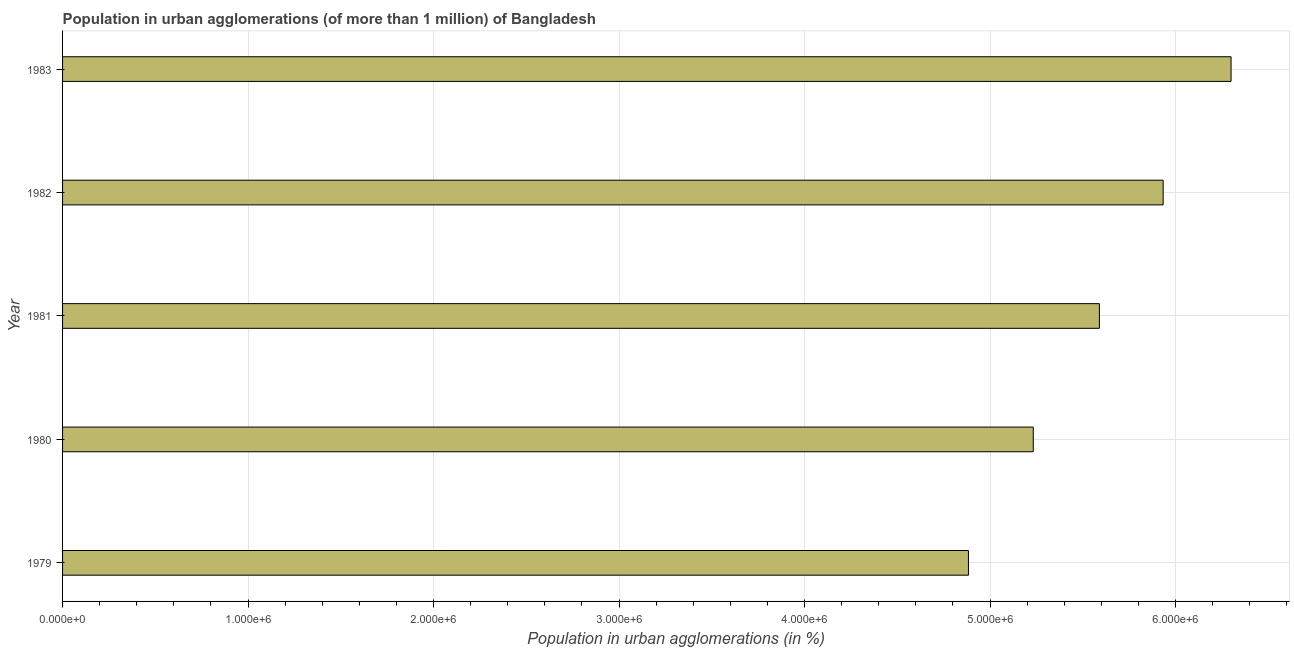Does the graph contain any zero values?
Offer a terse response. No. Does the graph contain grids?
Make the answer very short. Yes. What is the title of the graph?
Your response must be concise. Population in urban agglomerations (of more than 1 million) of Bangladesh. What is the label or title of the X-axis?
Provide a short and direct response. Population in urban agglomerations (in %). What is the label or title of the Y-axis?
Make the answer very short. Year. What is the population in urban agglomerations in 1983?
Your response must be concise. 6.30e+06. Across all years, what is the maximum population in urban agglomerations?
Give a very brief answer. 6.30e+06. Across all years, what is the minimum population in urban agglomerations?
Keep it short and to the point. 4.88e+06. In which year was the population in urban agglomerations minimum?
Your response must be concise. 1979. What is the sum of the population in urban agglomerations?
Keep it short and to the point. 2.79e+07. What is the difference between the population in urban agglomerations in 1979 and 1983?
Provide a succinct answer. -1.42e+06. What is the average population in urban agglomerations per year?
Your answer should be very brief. 5.59e+06. What is the median population in urban agglomerations?
Provide a succinct answer. 5.59e+06. Do a majority of the years between 1980 and 1981 (inclusive) have population in urban agglomerations greater than 1600000 %?
Make the answer very short. Yes. What is the ratio of the population in urban agglomerations in 1980 to that in 1983?
Ensure brevity in your answer.  0.83. What is the difference between the highest and the second highest population in urban agglomerations?
Your answer should be very brief. 3.66e+05. Is the sum of the population in urban agglomerations in 1979 and 1980 greater than the maximum population in urban agglomerations across all years?
Your answer should be very brief. Yes. What is the difference between the highest and the lowest population in urban agglomerations?
Your answer should be very brief. 1.42e+06. In how many years, is the population in urban agglomerations greater than the average population in urban agglomerations taken over all years?
Offer a very short reply. 3. How many bars are there?
Ensure brevity in your answer.  5. What is the Population in urban agglomerations (in %) in 1979?
Your response must be concise. 4.88e+06. What is the Population in urban agglomerations (in %) of 1980?
Provide a short and direct response. 5.23e+06. What is the Population in urban agglomerations (in %) of 1981?
Keep it short and to the point. 5.59e+06. What is the Population in urban agglomerations (in %) in 1982?
Your response must be concise. 5.93e+06. What is the Population in urban agglomerations (in %) in 1983?
Offer a terse response. 6.30e+06. What is the difference between the Population in urban agglomerations (in %) in 1979 and 1980?
Provide a short and direct response. -3.49e+05. What is the difference between the Population in urban agglomerations (in %) in 1979 and 1981?
Your answer should be compact. -7.06e+05. What is the difference between the Population in urban agglomerations (in %) in 1979 and 1982?
Offer a terse response. -1.05e+06. What is the difference between the Population in urban agglomerations (in %) in 1979 and 1983?
Your response must be concise. -1.42e+06. What is the difference between the Population in urban agglomerations (in %) in 1980 and 1981?
Ensure brevity in your answer.  -3.57e+05. What is the difference between the Population in urban agglomerations (in %) in 1980 and 1982?
Keep it short and to the point. -7.00e+05. What is the difference between the Population in urban agglomerations (in %) in 1980 and 1983?
Provide a succinct answer. -1.07e+06. What is the difference between the Population in urban agglomerations (in %) in 1981 and 1982?
Provide a succinct answer. -3.44e+05. What is the difference between the Population in urban agglomerations (in %) in 1981 and 1983?
Make the answer very short. -7.10e+05. What is the difference between the Population in urban agglomerations (in %) in 1982 and 1983?
Your answer should be very brief. -3.66e+05. What is the ratio of the Population in urban agglomerations (in %) in 1979 to that in 1980?
Offer a terse response. 0.93. What is the ratio of the Population in urban agglomerations (in %) in 1979 to that in 1981?
Provide a succinct answer. 0.87. What is the ratio of the Population in urban agglomerations (in %) in 1979 to that in 1982?
Make the answer very short. 0.82. What is the ratio of the Population in urban agglomerations (in %) in 1979 to that in 1983?
Make the answer very short. 0.78. What is the ratio of the Population in urban agglomerations (in %) in 1980 to that in 1981?
Offer a very short reply. 0.94. What is the ratio of the Population in urban agglomerations (in %) in 1980 to that in 1982?
Your answer should be compact. 0.88. What is the ratio of the Population in urban agglomerations (in %) in 1980 to that in 1983?
Ensure brevity in your answer.  0.83. What is the ratio of the Population in urban agglomerations (in %) in 1981 to that in 1982?
Keep it short and to the point. 0.94. What is the ratio of the Population in urban agglomerations (in %) in 1981 to that in 1983?
Give a very brief answer. 0.89. What is the ratio of the Population in urban agglomerations (in %) in 1982 to that in 1983?
Make the answer very short. 0.94. 